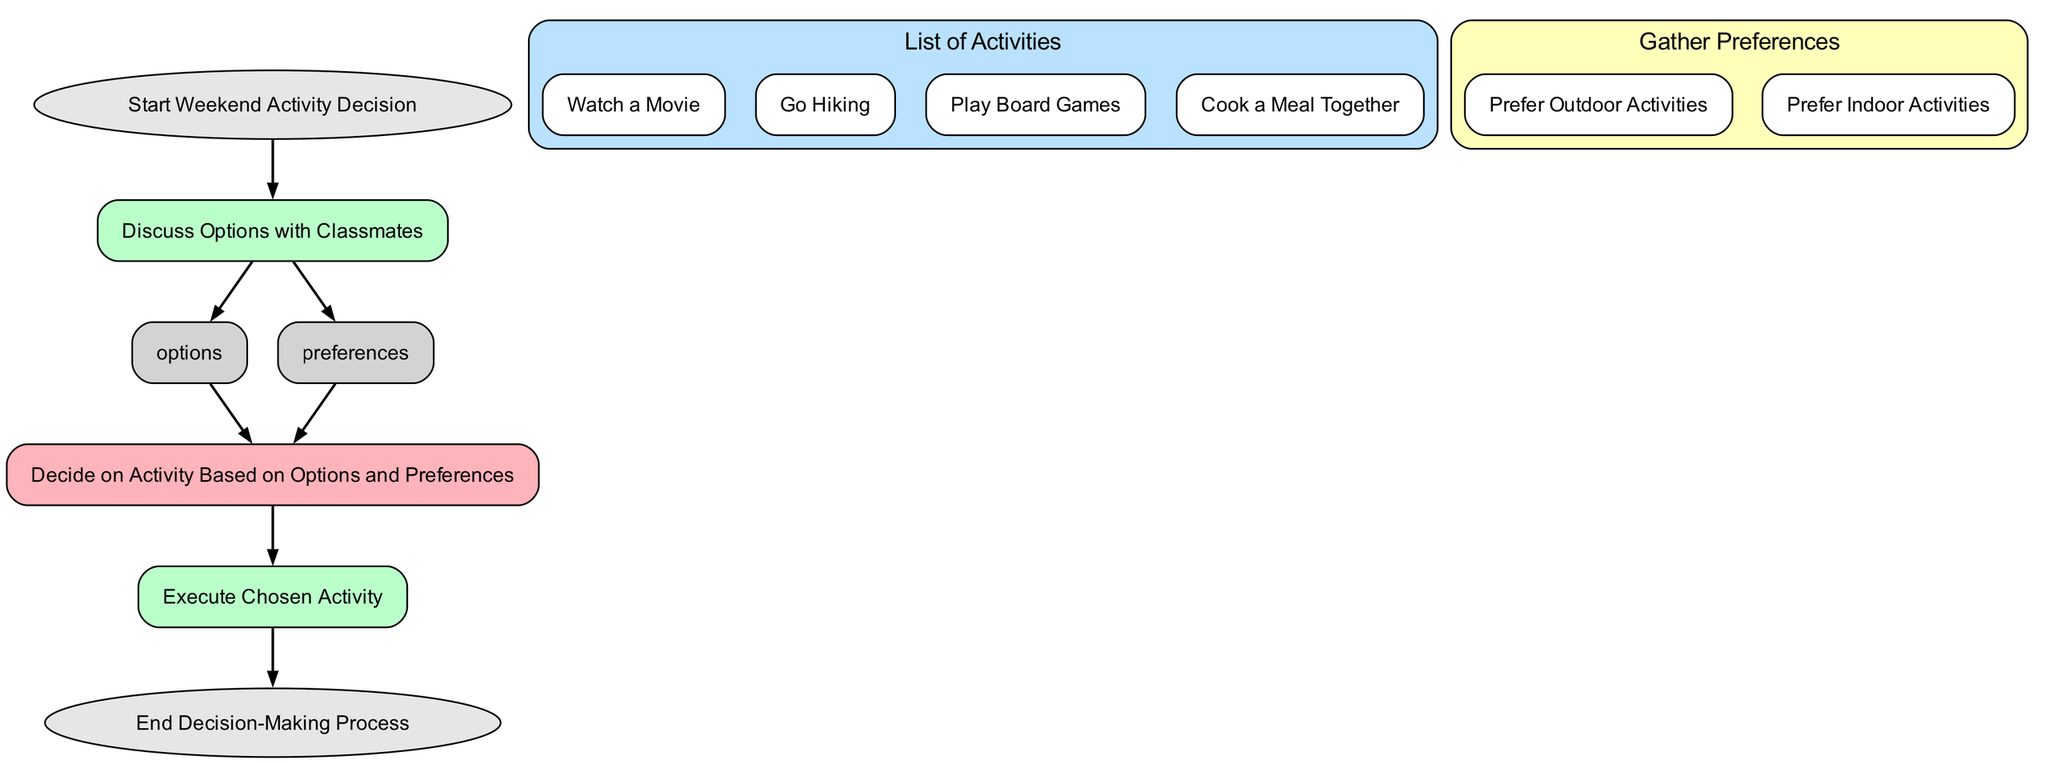What is the first step in the decision-making process? The first step in the flow chart is indicated by the "Start Weekend Activity Decision" node. This node is at the top of the diagram, signifying the initiation of the process.
Answer: Start Weekend Activity Decision How many main options are there for activities? The number of options can be found in the "List of Activities" node, which includes four specific activities: watching a movie, going hiking, playing board games, and cooking a meal together. This totals four options.
Answer: Four What are the two types of preferences gathered? The preferences are specified in the "Gather Preferences" node, which includes two distinct child nodes: "Prefer Outdoor Activities" and "Prefer Indoor Activities." This indicates that the preferences are categorized into outdoor and indoor activities.
Answer: Prefer Outdoor Activities, Prefer Indoor Activities Which node leads to executing the chosen activity? The node leading to executing the chosen activity is "Decide on Activity Based on Options and Preferences." This node compiles inputs from both the options and preferences nodes to determine what activity will be executed next.
Answer: Decide on Activity Based on Options and Preferences What is the final node in the flowchart? The final node in the flow chart is labeled "End Decision-Making Process." This node signifies the completion of the decision-making sequence and is located at the bottom of the diagram.
Answer: End Decision-Making Process Explain the flow of information from discussing options to deciding on an activity. The flow starts at the "Discuss Options with Classmates" node. From there, it branches to "List of Activities" and "Gather Preferences" nodes. These two nodes provide input for the next step, "Decide on Activity Based on Options and Preferences," making it the crucial node that combines the options and preferences to reach a decision on the activity.
Answer: From discussing options, it branches to the list of activities and preferences, before leading to deciding on an activity 